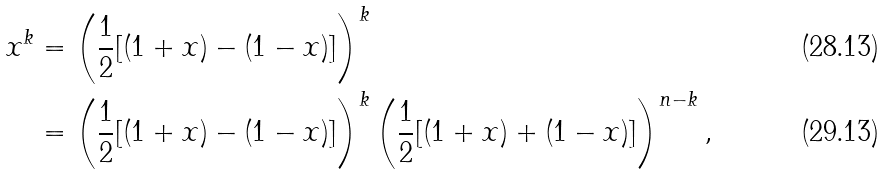<formula> <loc_0><loc_0><loc_500><loc_500>x ^ { k } & = \left ( \frac { 1 } { 2 } [ ( 1 + x ) - ( 1 - x ) ] \right ) ^ { k } \\ & = \left ( \frac { 1 } { 2 } [ ( 1 + x ) - ( 1 - x ) ] \right ) ^ { k } \left ( \frac { 1 } { 2 } [ ( 1 + x ) + ( 1 - x ) ] \right ) ^ { n - k } ,</formula> 